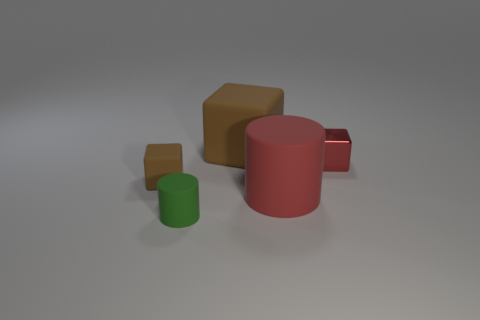Add 1 big cyan cylinders. How many objects exist? 6 Subtract all cubes. How many objects are left? 2 Subtract all big brown rubber objects. Subtract all small brown blocks. How many objects are left? 3 Add 2 tiny green matte cylinders. How many tiny green matte cylinders are left? 3 Add 1 small green rubber objects. How many small green rubber objects exist? 2 Subtract 0 gray cubes. How many objects are left? 5 